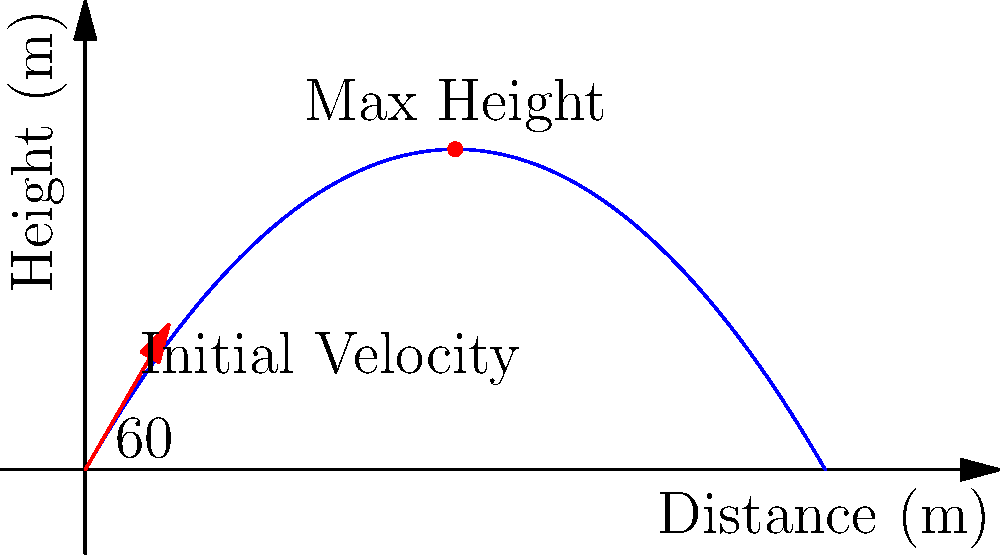In a crime scene reconstruction, you need to determine the maximum height reached by a projectile launched at an angle of 60° from the ground with an initial velocity of 50 m/s. What is the maximum height reached by the projectile? To find the maximum height of the projectile, we'll follow these steps:

1) The time to reach maximum height is half the total flight time. We can find this using the vertical component of velocity:

   $v_y = v_0 \sin{\theta} - gt$

   At the highest point, $v_y = 0$, so:
   
   $0 = v_0 \sin{\theta} - gt_{max}$
   $t_{max} = \frac{v_0 \sin{\theta}}{g}$

2) Initial vertical velocity:
   $v_0y = v_0 \sin{\theta} = 50 \sin{60°} = 43.3$ m/s

3) Time to reach maximum height:
   $t_{max} = \frac{43.3}{9.8} = 4.42$ s

4) Now we can use the equation for displacement to find the maximum height:

   $y = v_0y \cdot t - \frac{1}{2}gt^2$

   $y_{max} = 43.3 \cdot 4.42 - \frac{1}{2} \cdot 9.8 \cdot 4.42^2$
   
   $y_{max} = 191.4 - 95.7 = 95.7$ m

Therefore, the maximum height reached by the projectile is approximately 95.7 meters.
Answer: 95.7 meters 